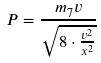<formula> <loc_0><loc_0><loc_500><loc_500>P = \frac { m _ { 7 } v } { \sqrt { 8 \cdot \frac { v ^ { 2 } } { x ^ { 2 } } } }</formula> 